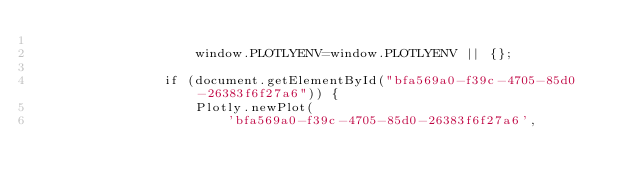Convert code to text. <code><loc_0><loc_0><loc_500><loc_500><_HTML_>                
                    window.PLOTLYENV=window.PLOTLYENV || {};
                    
                if (document.getElementById("bfa569a0-f39c-4705-85d0-26383f6f27a6")) {
                    Plotly.newPlot(
                        'bfa569a0-f39c-4705-85d0-26383f6f27a6',</code> 